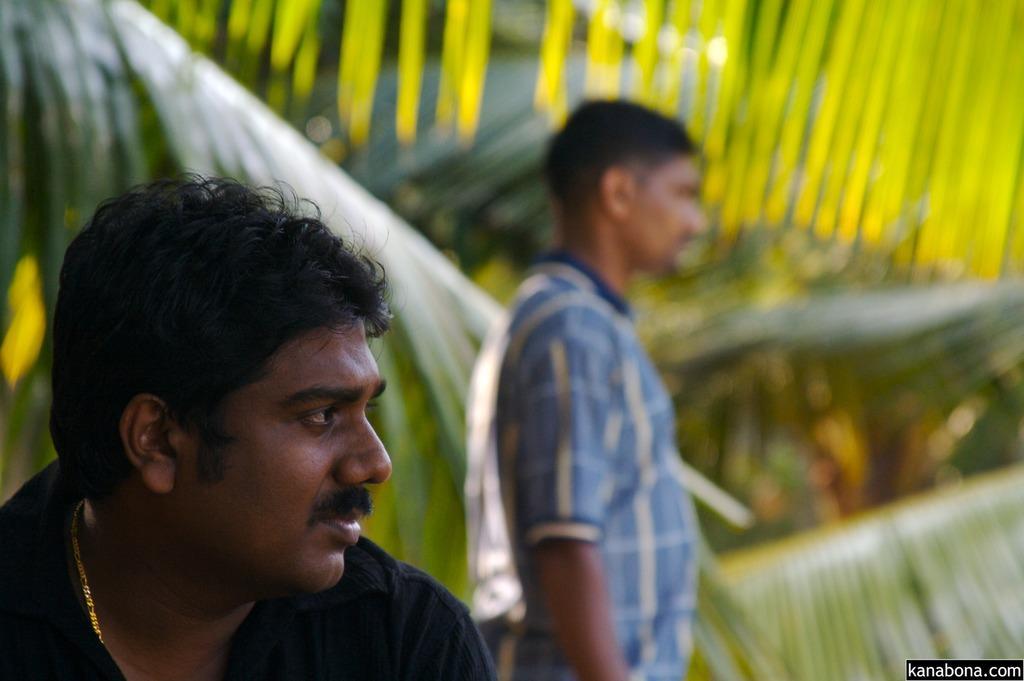How would you summarize this image in a sentence or two? In this image there are two people, behind them there are leaves of coconut trees, at the bottom of the image there is some text. 